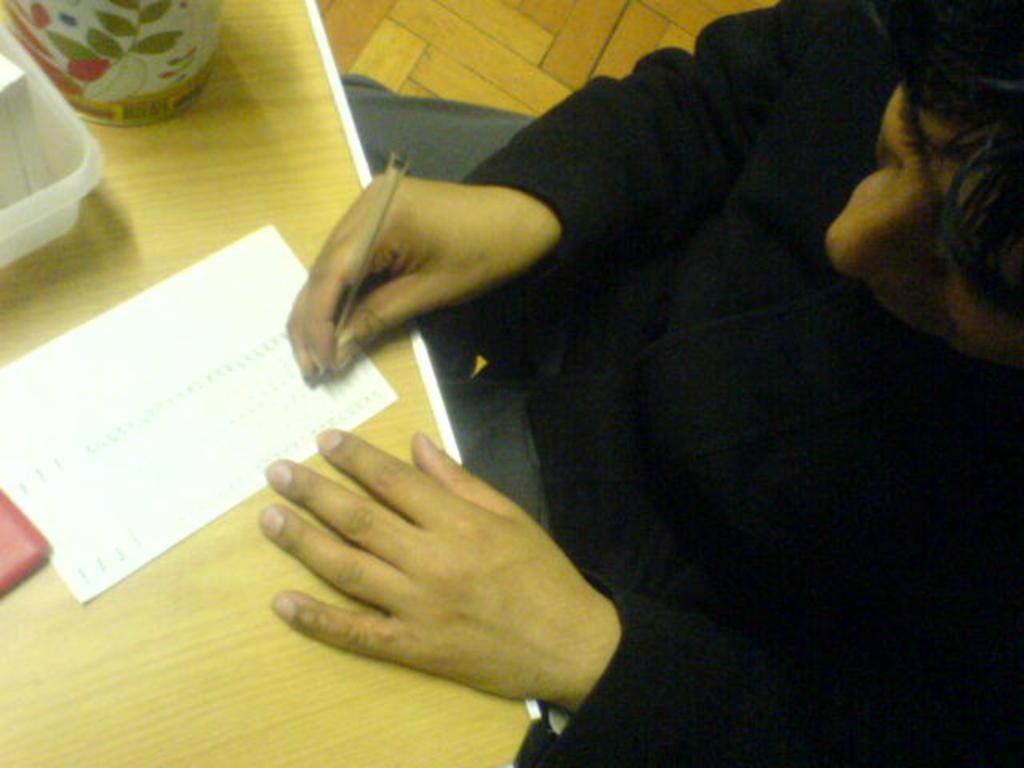Who is the person in the image? The facts provided do not specify the person's identity. What is the person doing in the image? The person is writing on a paper. What tool is the person using to write? There is a pen in the image. What surface is the person writing on? The person is writing on a table. What else can be seen on the table? There are objects on the table. What type of rat is hiding under the table in the image? There is no rat present in the image. How much dust can be seen on the objects on the table in the image? The facts provided do not mention any dust on the objects in the image. 